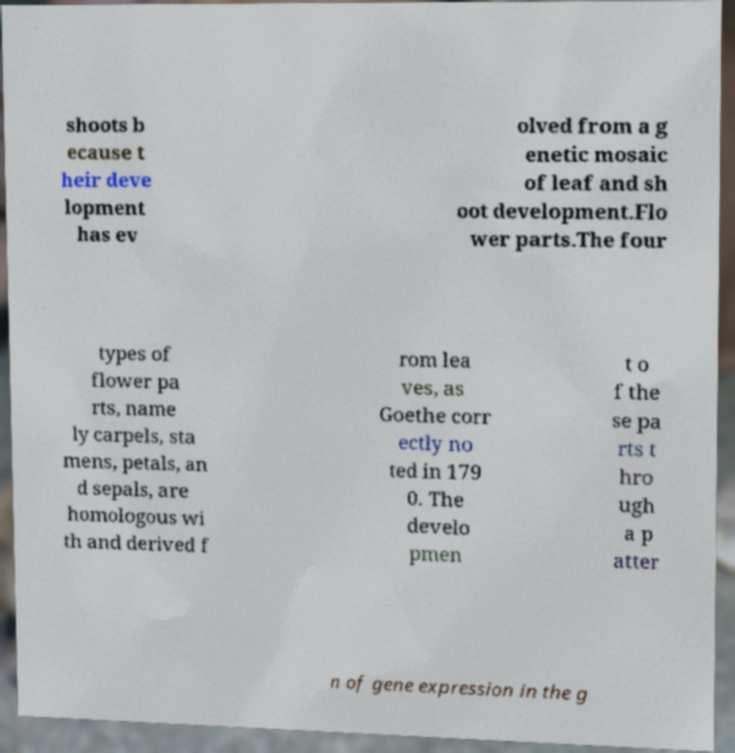Please read and relay the text visible in this image. What does it say? shoots b ecause t heir deve lopment has ev olved from a g enetic mosaic of leaf and sh oot development.Flo wer parts.The four types of flower pa rts, name ly carpels, sta mens, petals, an d sepals, are homologous wi th and derived f rom lea ves, as Goethe corr ectly no ted in 179 0. The develo pmen t o f the se pa rts t hro ugh a p atter n of gene expression in the g 